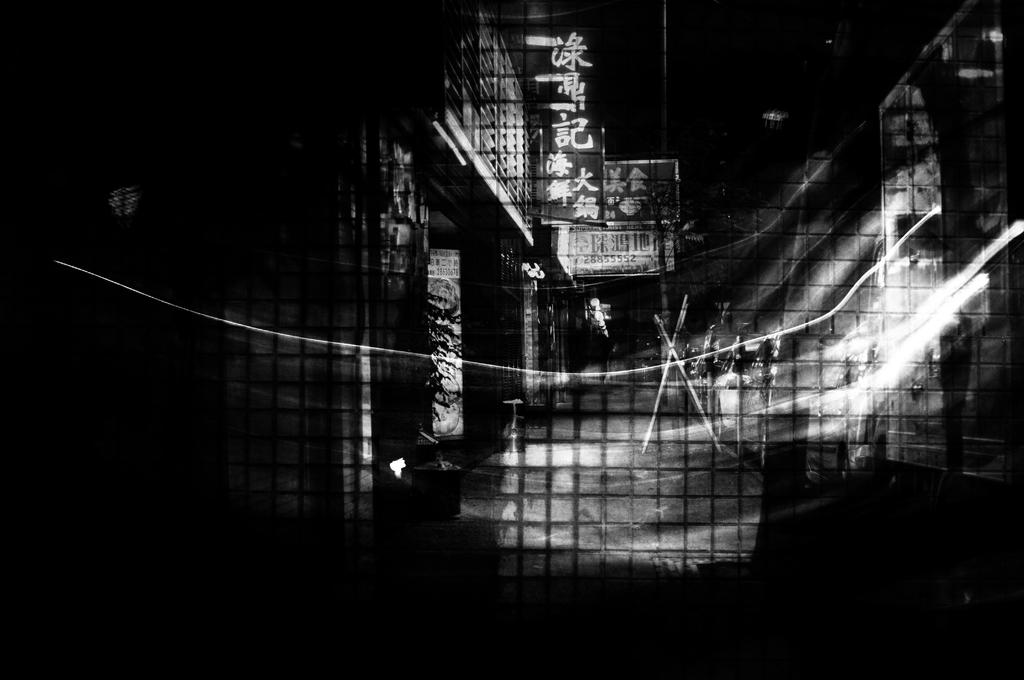What is the color scheme of the image? The image is dark and black and white. What type of structures can be seen in the image? There are buildings in the image. What is placed in front of the buildings? There are posters in front of the buildings. Where are the lights located in the image? The lights are visible on the right side of the image. Can you see any corn growing in the image? There is no corn visible in the image. Is there a body of water present in the image? There is no body of water mentioned in the provided facts, and therefore it cannot be determined from the image. 